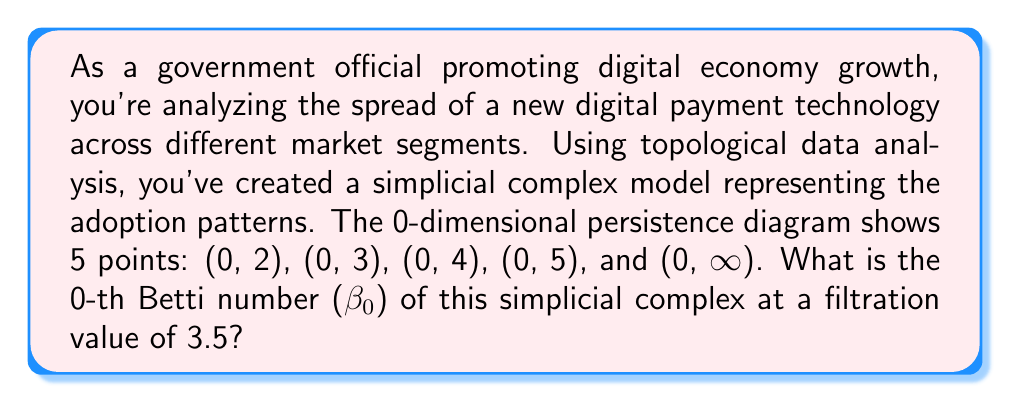Can you solve this math problem? To solve this problem, we need to understand the concepts of persistent homology and Betti numbers in topological data analysis:

1) The 0-th Betti number (β₀) represents the number of connected components in the simplicial complex.

2) The persistence diagram shows the birth and death times of topological features (in this case, connected components) as the filtration value increases.

3) Points in the persistence diagram are represented as (birth, death) pairs.

4) The ∞ symbol indicates a feature that never dies (persists indefinitely).

5) To find β₀ at a specific filtration value, we count the number of points in the persistence diagram that:
   a) Were born at or before the filtration value
   b) Die after the filtration value (or never die)

Given:
- Filtration value: 3.5
- Persistence diagram points: (0, 2), (0, 3), (0, 4), (0, 5), (0, ∞)

Step-by-step analysis:
1) All points have a birth time of 0, so they all satisfy condition (a).

2) Let's check each point against condition (b):
   - (0, 2): Dies before 3.5, doesn't count
   - (0, 3): Dies before 3.5, doesn't count
   - (0, 4): Dies after 3.5, counts
   - (0, 5): Dies after 3.5, counts
   - (0, ∞): Never dies, counts

3) Counting the points that satisfy both conditions, we get 3.

Therefore, at a filtration value of 3.5, there are 3 connected components in the simplicial complex, so β₀ = 3.
Answer: The 0-th Betti number (β₀) of the simplicial complex at a filtration value of 3.5 is 3. 